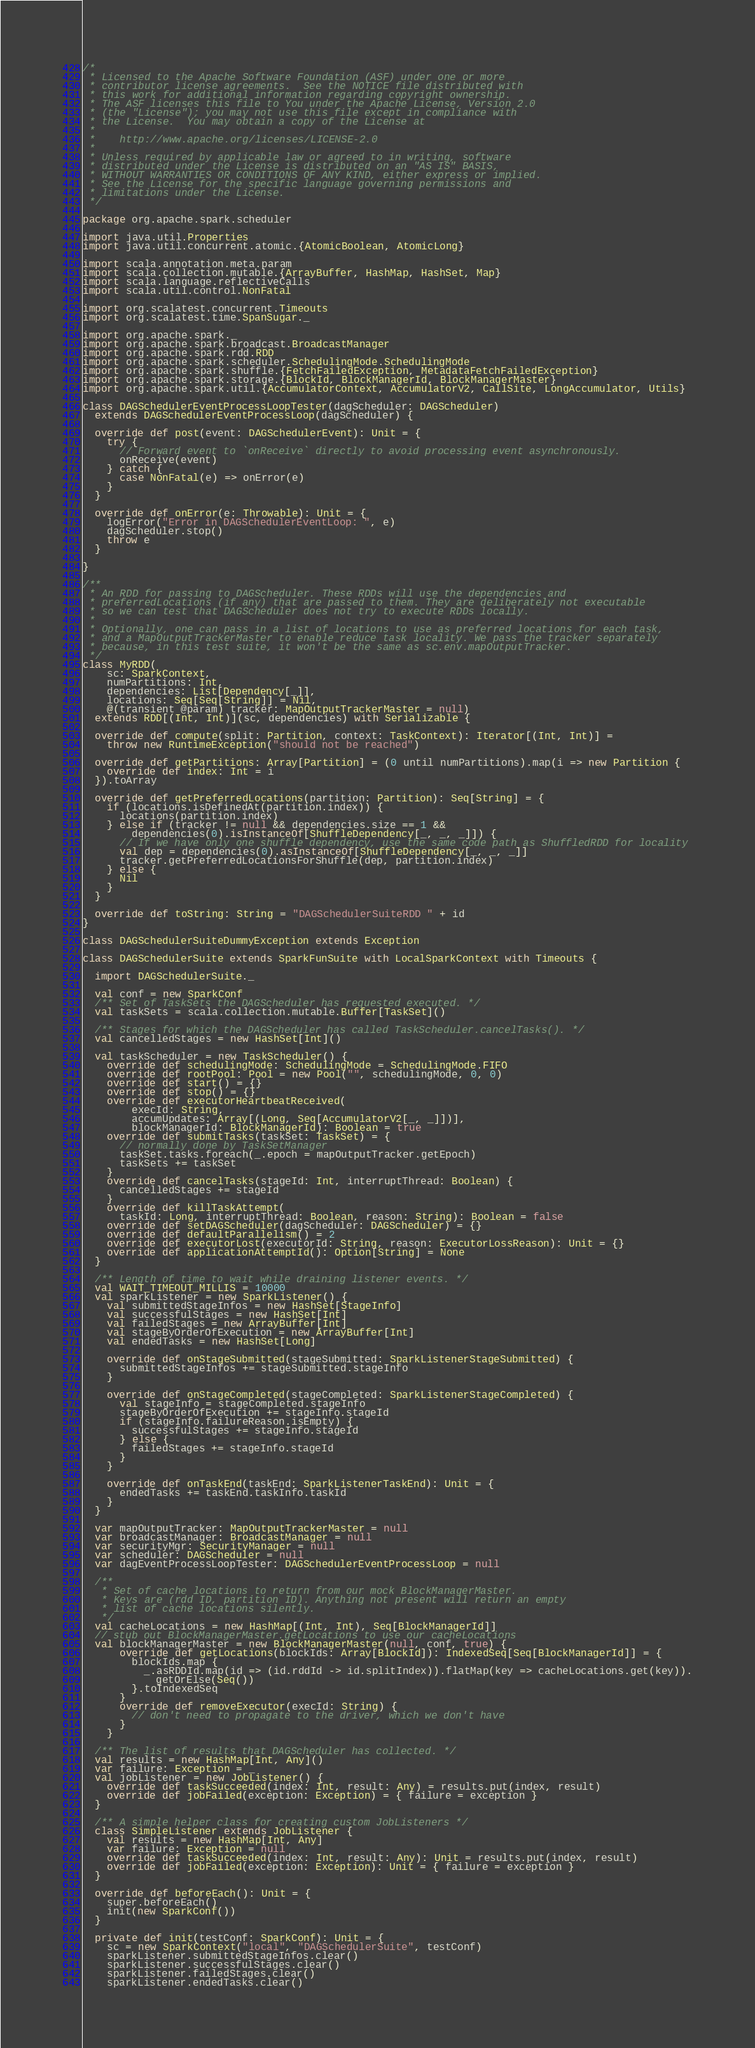Convert code to text. <code><loc_0><loc_0><loc_500><loc_500><_Scala_>/*
 * Licensed to the Apache Software Foundation (ASF) under one or more
 * contributor license agreements.  See the NOTICE file distributed with
 * this work for additional information regarding copyright ownership.
 * The ASF licenses this file to You under the Apache License, Version 2.0
 * (the "License"); you may not use this file except in compliance with
 * the License.  You may obtain a copy of the License at
 *
 *    http://www.apache.org/licenses/LICENSE-2.0
 *
 * Unless required by applicable law or agreed to in writing, software
 * distributed under the License is distributed on an "AS IS" BASIS,
 * WITHOUT WARRANTIES OR CONDITIONS OF ANY KIND, either express or implied.
 * See the License for the specific language governing permissions and
 * limitations under the License.
 */

package org.apache.spark.scheduler

import java.util.Properties
import java.util.concurrent.atomic.{AtomicBoolean, AtomicLong}

import scala.annotation.meta.param
import scala.collection.mutable.{ArrayBuffer, HashMap, HashSet, Map}
import scala.language.reflectiveCalls
import scala.util.control.NonFatal

import org.scalatest.concurrent.Timeouts
import org.scalatest.time.SpanSugar._

import org.apache.spark._
import org.apache.spark.broadcast.BroadcastManager
import org.apache.spark.rdd.RDD
import org.apache.spark.scheduler.SchedulingMode.SchedulingMode
import org.apache.spark.shuffle.{FetchFailedException, MetadataFetchFailedException}
import org.apache.spark.storage.{BlockId, BlockManagerId, BlockManagerMaster}
import org.apache.spark.util.{AccumulatorContext, AccumulatorV2, CallSite, LongAccumulator, Utils}

class DAGSchedulerEventProcessLoopTester(dagScheduler: DAGScheduler)
  extends DAGSchedulerEventProcessLoop(dagScheduler) {

  override def post(event: DAGSchedulerEvent): Unit = {
    try {
      // Forward event to `onReceive` directly to avoid processing event asynchronously.
      onReceive(event)
    } catch {
      case NonFatal(e) => onError(e)
    }
  }

  override def onError(e: Throwable): Unit = {
    logError("Error in DAGSchedulerEventLoop: ", e)
    dagScheduler.stop()
    throw e
  }

}

/**
 * An RDD for passing to DAGScheduler. These RDDs will use the dependencies and
 * preferredLocations (if any) that are passed to them. They are deliberately not executable
 * so we can test that DAGScheduler does not try to execute RDDs locally.
 *
 * Optionally, one can pass in a list of locations to use as preferred locations for each task,
 * and a MapOutputTrackerMaster to enable reduce task locality. We pass the tracker separately
 * because, in this test suite, it won't be the same as sc.env.mapOutputTracker.
 */
class MyRDD(
    sc: SparkContext,
    numPartitions: Int,
    dependencies: List[Dependency[_]],
    locations: Seq[Seq[String]] = Nil,
    @(transient @param) tracker: MapOutputTrackerMaster = null)
  extends RDD[(Int, Int)](sc, dependencies) with Serializable {

  override def compute(split: Partition, context: TaskContext): Iterator[(Int, Int)] =
    throw new RuntimeException("should not be reached")

  override def getPartitions: Array[Partition] = (0 until numPartitions).map(i => new Partition {
    override def index: Int = i
  }).toArray

  override def getPreferredLocations(partition: Partition): Seq[String] = {
    if (locations.isDefinedAt(partition.index)) {
      locations(partition.index)
    } else if (tracker != null && dependencies.size == 1 &&
        dependencies(0).isInstanceOf[ShuffleDependency[_, _, _]]) {
      // If we have only one shuffle dependency, use the same code path as ShuffledRDD for locality
      val dep = dependencies(0).asInstanceOf[ShuffleDependency[_, _, _]]
      tracker.getPreferredLocationsForShuffle(dep, partition.index)
    } else {
      Nil
    }
  }

  override def toString: String = "DAGSchedulerSuiteRDD " + id
}

class DAGSchedulerSuiteDummyException extends Exception

class DAGSchedulerSuite extends SparkFunSuite with LocalSparkContext with Timeouts {

  import DAGSchedulerSuite._

  val conf = new SparkConf
  /** Set of TaskSets the DAGScheduler has requested executed. */
  val taskSets = scala.collection.mutable.Buffer[TaskSet]()

  /** Stages for which the DAGScheduler has called TaskScheduler.cancelTasks(). */
  val cancelledStages = new HashSet[Int]()

  val taskScheduler = new TaskScheduler() {
    override def schedulingMode: SchedulingMode = SchedulingMode.FIFO
    override def rootPool: Pool = new Pool("", schedulingMode, 0, 0)
    override def start() = {}
    override def stop() = {}
    override def executorHeartbeatReceived(
        execId: String,
        accumUpdates: Array[(Long, Seq[AccumulatorV2[_, _]])],
        blockManagerId: BlockManagerId): Boolean = true
    override def submitTasks(taskSet: TaskSet) = {
      // normally done by TaskSetManager
      taskSet.tasks.foreach(_.epoch = mapOutputTracker.getEpoch)
      taskSets += taskSet
    }
    override def cancelTasks(stageId: Int, interruptThread: Boolean) {
      cancelledStages += stageId
    }
    override def killTaskAttempt(
      taskId: Long, interruptThread: Boolean, reason: String): Boolean = false
    override def setDAGScheduler(dagScheduler: DAGScheduler) = {}
    override def defaultParallelism() = 2
    override def executorLost(executorId: String, reason: ExecutorLossReason): Unit = {}
    override def applicationAttemptId(): Option[String] = None
  }

  /** Length of time to wait while draining listener events. */
  val WAIT_TIMEOUT_MILLIS = 10000
  val sparkListener = new SparkListener() {
    val submittedStageInfos = new HashSet[StageInfo]
    val successfulStages = new HashSet[Int]
    val failedStages = new ArrayBuffer[Int]
    val stageByOrderOfExecution = new ArrayBuffer[Int]
    val endedTasks = new HashSet[Long]

    override def onStageSubmitted(stageSubmitted: SparkListenerStageSubmitted) {
      submittedStageInfos += stageSubmitted.stageInfo
    }

    override def onStageCompleted(stageCompleted: SparkListenerStageCompleted) {
      val stageInfo = stageCompleted.stageInfo
      stageByOrderOfExecution += stageInfo.stageId
      if (stageInfo.failureReason.isEmpty) {
        successfulStages += stageInfo.stageId
      } else {
        failedStages += stageInfo.stageId
      }
    }

    override def onTaskEnd(taskEnd: SparkListenerTaskEnd): Unit = {
      endedTasks += taskEnd.taskInfo.taskId
    }
  }

  var mapOutputTracker: MapOutputTrackerMaster = null
  var broadcastManager: BroadcastManager = null
  var securityMgr: SecurityManager = null
  var scheduler: DAGScheduler = null
  var dagEventProcessLoopTester: DAGSchedulerEventProcessLoop = null

  /**
   * Set of cache locations to return from our mock BlockManagerMaster.
   * Keys are (rdd ID, partition ID). Anything not present will return an empty
   * list of cache locations silently.
   */
  val cacheLocations = new HashMap[(Int, Int), Seq[BlockManagerId]]
  // stub out BlockManagerMaster.getLocations to use our cacheLocations
  val blockManagerMaster = new BlockManagerMaster(null, conf, true) {
      override def getLocations(blockIds: Array[BlockId]): IndexedSeq[Seq[BlockManagerId]] = {
        blockIds.map {
          _.asRDDId.map(id => (id.rddId -> id.splitIndex)).flatMap(key => cacheLocations.get(key)).
            getOrElse(Seq())
        }.toIndexedSeq
      }
      override def removeExecutor(execId: String) {
        // don't need to propagate to the driver, which we don't have
      }
    }

  /** The list of results that DAGScheduler has collected. */
  val results = new HashMap[Int, Any]()
  var failure: Exception = _
  val jobListener = new JobListener() {
    override def taskSucceeded(index: Int, result: Any) = results.put(index, result)
    override def jobFailed(exception: Exception) = { failure = exception }
  }

  /** A simple helper class for creating custom JobListeners */
  class SimpleListener extends JobListener {
    val results = new HashMap[Int, Any]
    var failure: Exception = null
    override def taskSucceeded(index: Int, result: Any): Unit = results.put(index, result)
    override def jobFailed(exception: Exception): Unit = { failure = exception }
  }

  override def beforeEach(): Unit = {
    super.beforeEach()
    init(new SparkConf())
  }

  private def init(testConf: SparkConf): Unit = {
    sc = new SparkContext("local", "DAGSchedulerSuite", testConf)
    sparkListener.submittedStageInfos.clear()
    sparkListener.successfulStages.clear()
    sparkListener.failedStages.clear()
    sparkListener.endedTasks.clear()</code> 